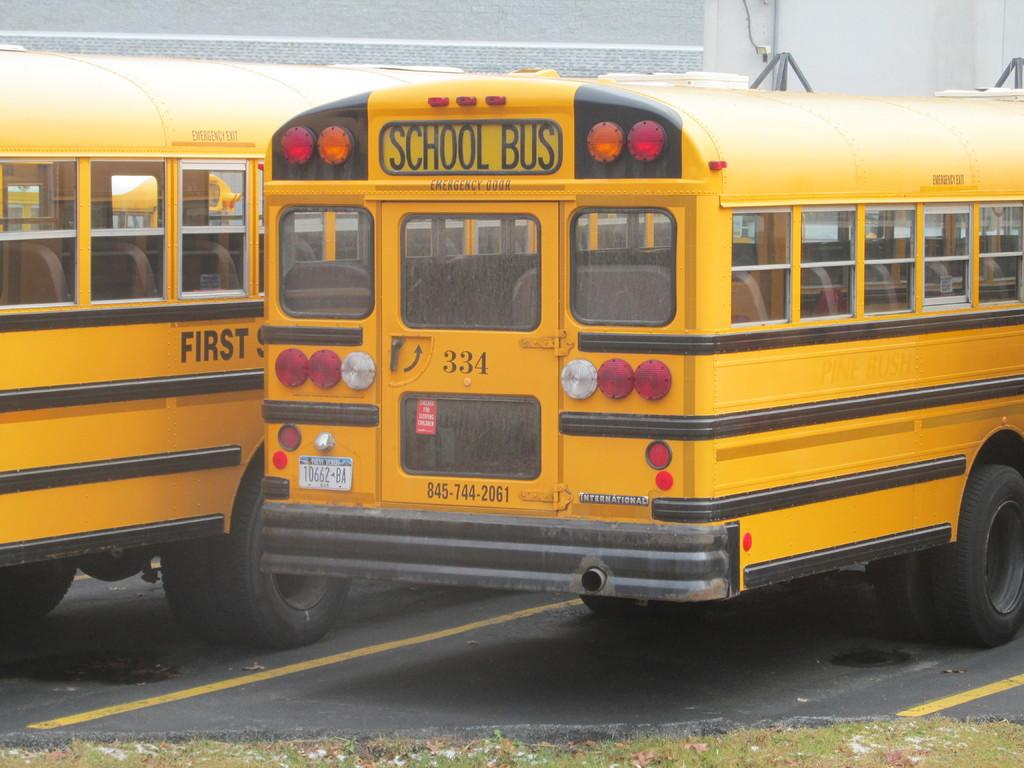What type of vehicles are on the road in the image? There are two buses on the road in the image. Where are the buses located in the image? The buses are in the middle of the image. What can be seen in the background of the image? There is a wall in the background of the image. How many knots are tied on the buses in the image? There are no knots present on the buses in the image. What letters can be seen on the buses in the image? The provided facts do not mention any letters on the buses, so we cannot determine if any letters are present. 